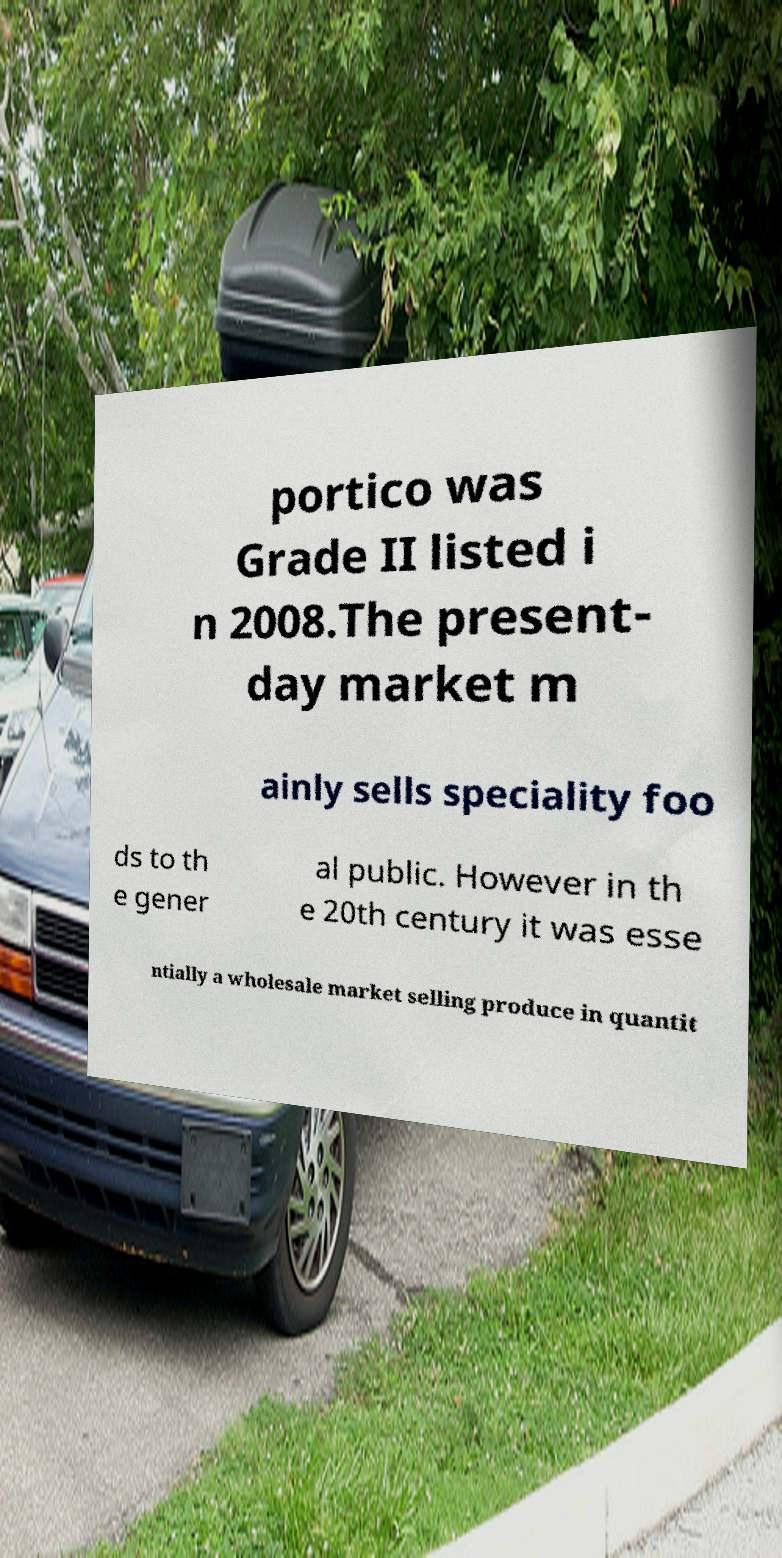Could you assist in decoding the text presented in this image and type it out clearly? portico was Grade II listed i n 2008.The present- day market m ainly sells speciality foo ds to th e gener al public. However in th e 20th century it was esse ntially a wholesale market selling produce in quantit 